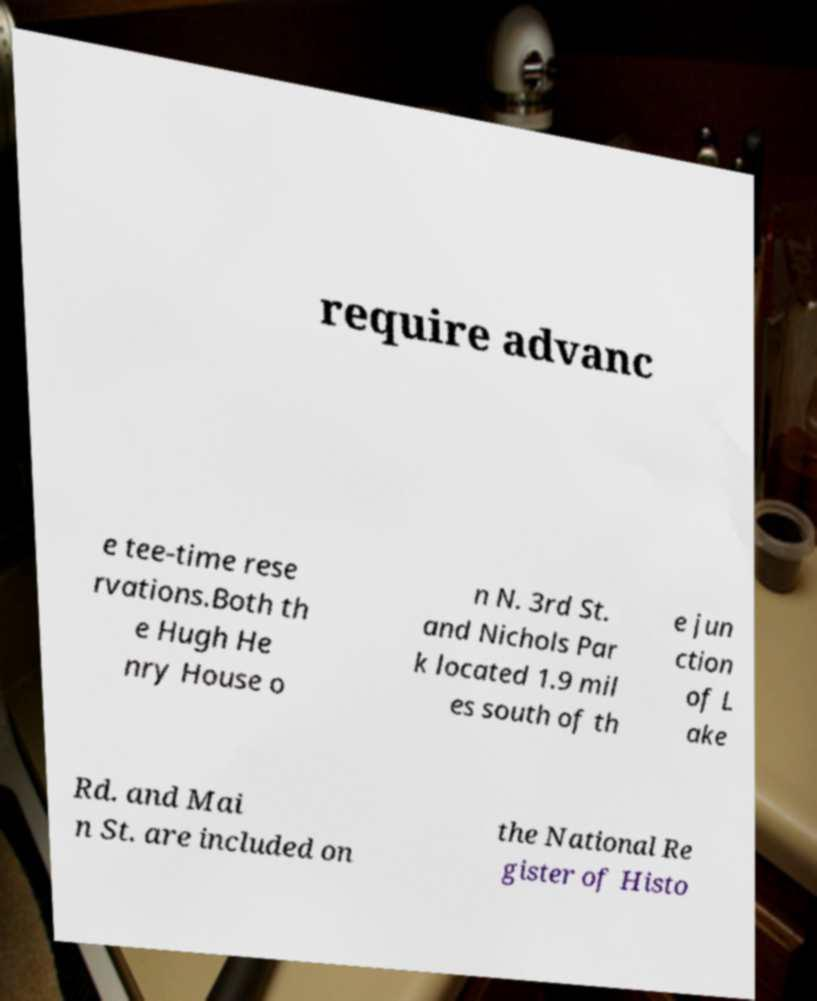There's text embedded in this image that I need extracted. Can you transcribe it verbatim? require advanc e tee-time rese rvations.Both th e Hugh He nry House o n N. 3rd St. and Nichols Par k located 1.9 mil es south of th e jun ction of L ake Rd. and Mai n St. are included on the National Re gister of Histo 